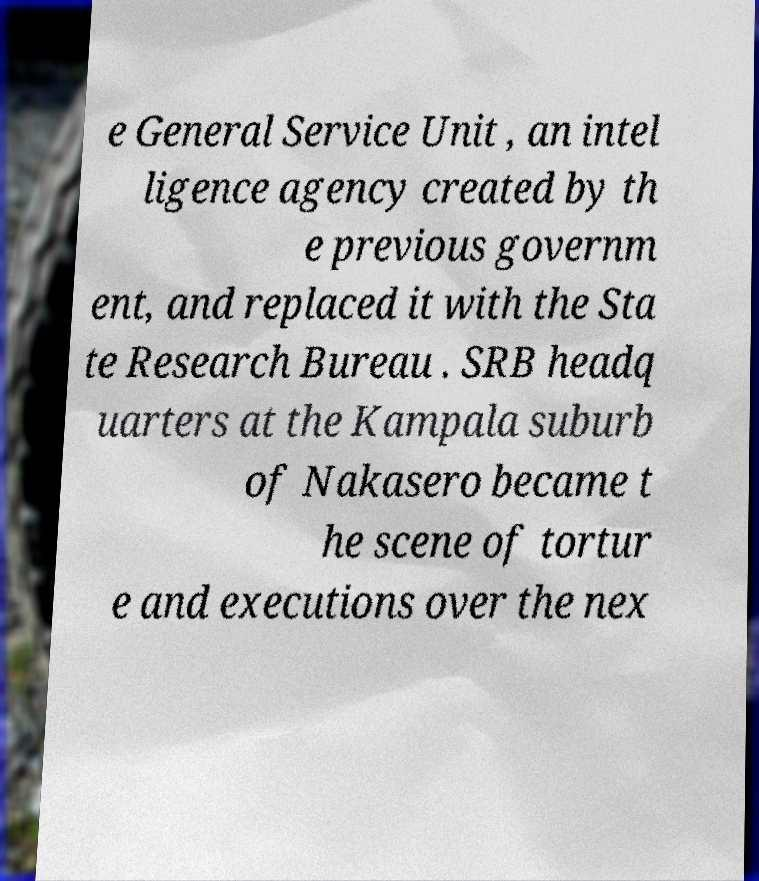Could you extract and type out the text from this image? e General Service Unit , an intel ligence agency created by th e previous governm ent, and replaced it with the Sta te Research Bureau . SRB headq uarters at the Kampala suburb of Nakasero became t he scene of tortur e and executions over the nex 